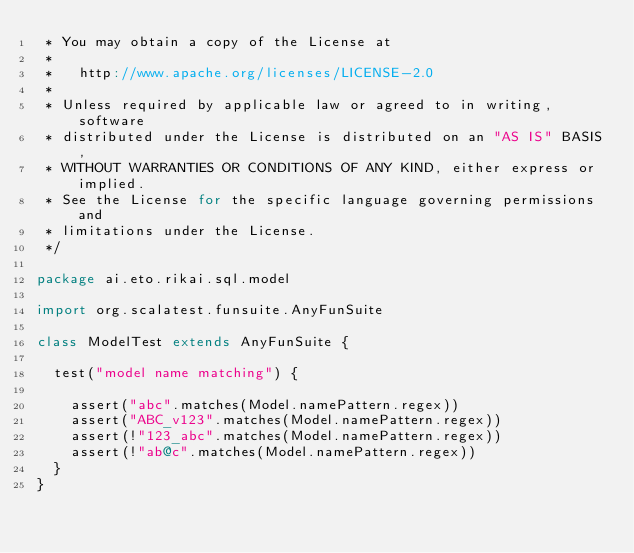<code> <loc_0><loc_0><loc_500><loc_500><_Scala_> * You may obtain a copy of the License at
 *
 *   http://www.apache.org/licenses/LICENSE-2.0
 *
 * Unless required by applicable law or agreed to in writing, software
 * distributed under the License is distributed on an "AS IS" BASIS,
 * WITHOUT WARRANTIES OR CONDITIONS OF ANY KIND, either express or implied.
 * See the License for the specific language governing permissions and
 * limitations under the License.
 */

package ai.eto.rikai.sql.model

import org.scalatest.funsuite.AnyFunSuite

class ModelTest extends AnyFunSuite {

  test("model name matching") {

    assert("abc".matches(Model.namePattern.regex))
    assert("ABC_v123".matches(Model.namePattern.regex))
    assert(!"123_abc".matches(Model.namePattern.regex))
    assert(!"ab@c".matches(Model.namePattern.regex))
  }
}
</code> 